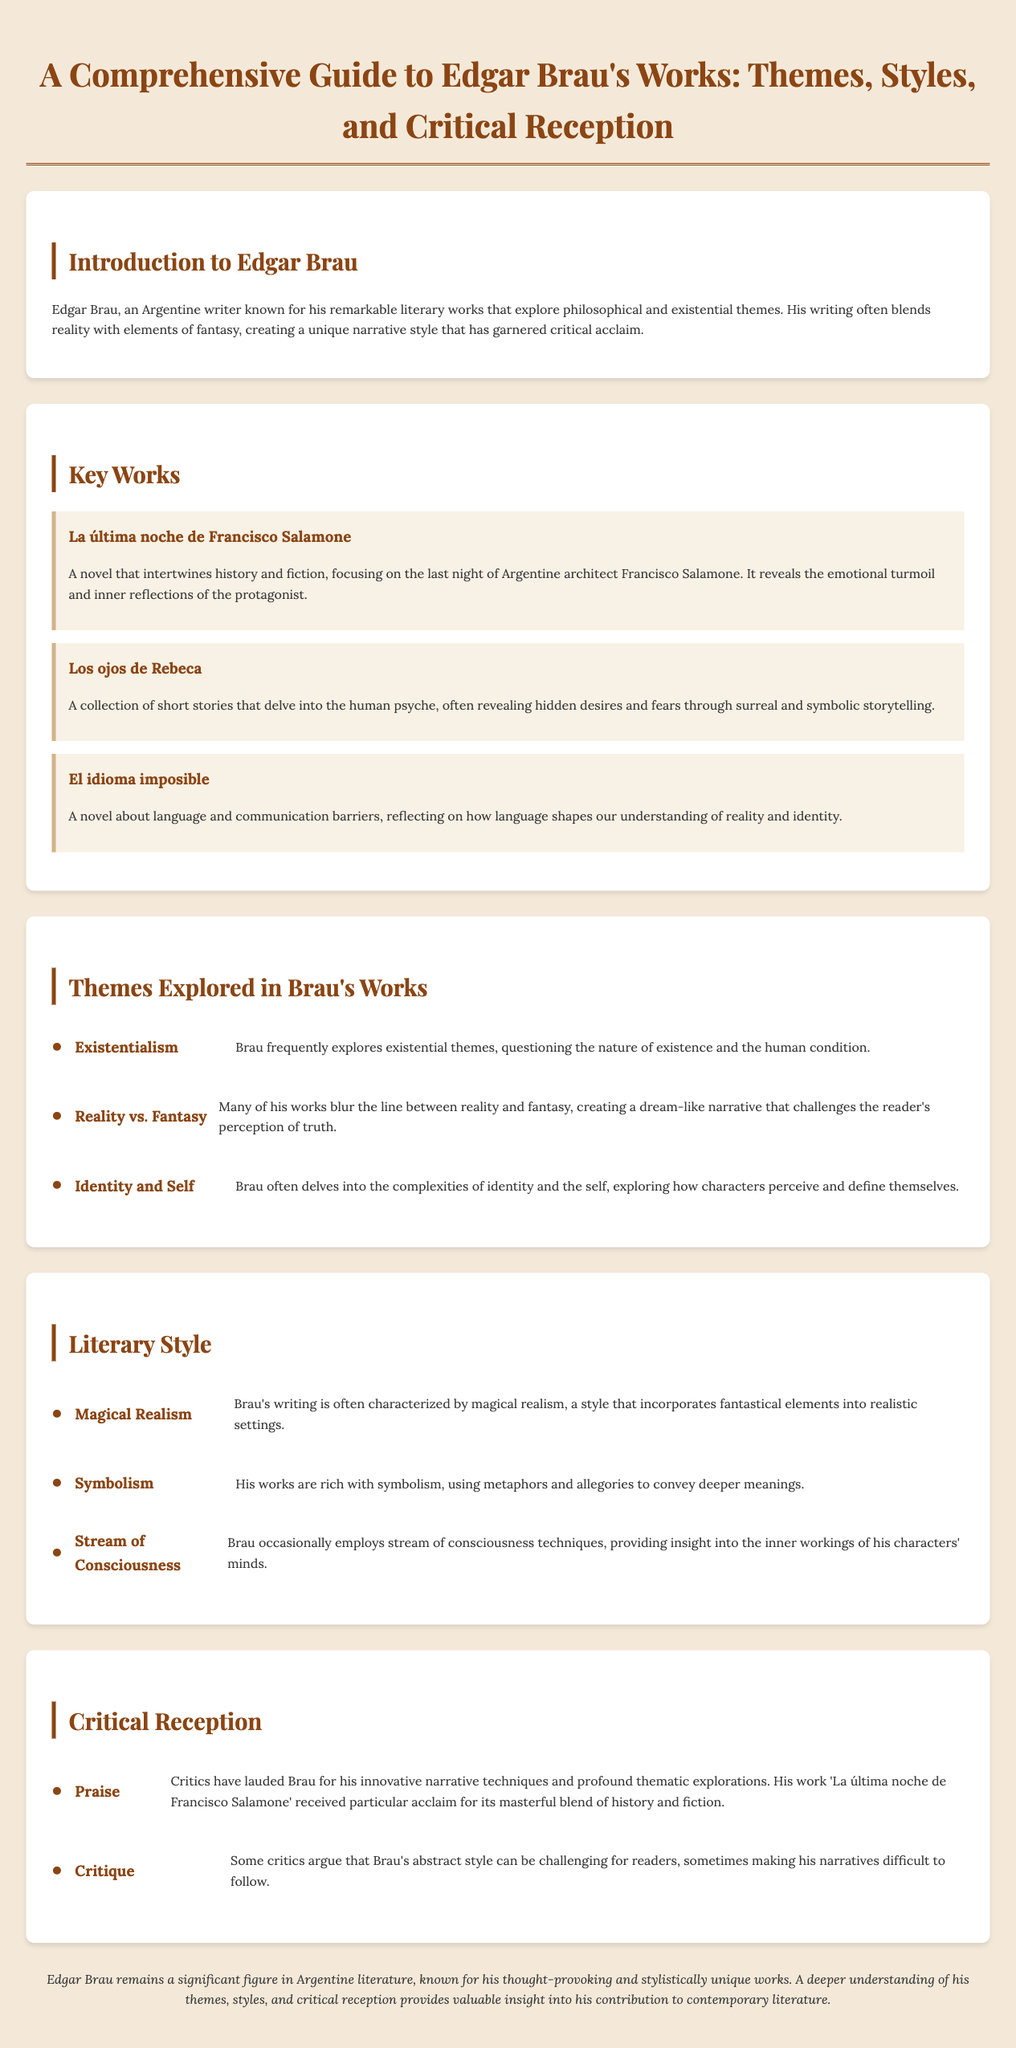what is the title of Edgar Brau's work that focuses on Francisco Salamone? The document explicitly states that the title is "La última noche de Francisco Salamone."
Answer: La última noche de Francisco Salamone which literary style is frequently characterized by magical elements in Brau's works? The document identifies "Magical Realism" as a key literary style used by Brau.
Answer: Magical Realism how many key works of Edgar Brau are listed in the document? The document presents a total of three key works by Edgar Brau.
Answer: 3 what theme does Brau often explore related to existence? The document mentions "Existentialism" as a recurring theme in Brau's works.
Answer: Existentialism what is the primary critique of Brau's literary style according to some critics? Critics point out that Brau's style can sometimes be "challenging for readers."
Answer: challenging for readers what unique narrative technique is praised in "La última noche de Francisco Salamone"? The document highlights the "masterful blend of history and fiction" as a notable technique.
Answer: masterful blend of history and fiction what psychological concept is a central focus in "Los ojos de Rebeca"? The work delves into the "human psyche" as stated in the document.
Answer: human psyche what type of document is being described? The document is a "Comprehensive Guide" to Edgar Brau's works.
Answer: Comprehensive Guide 